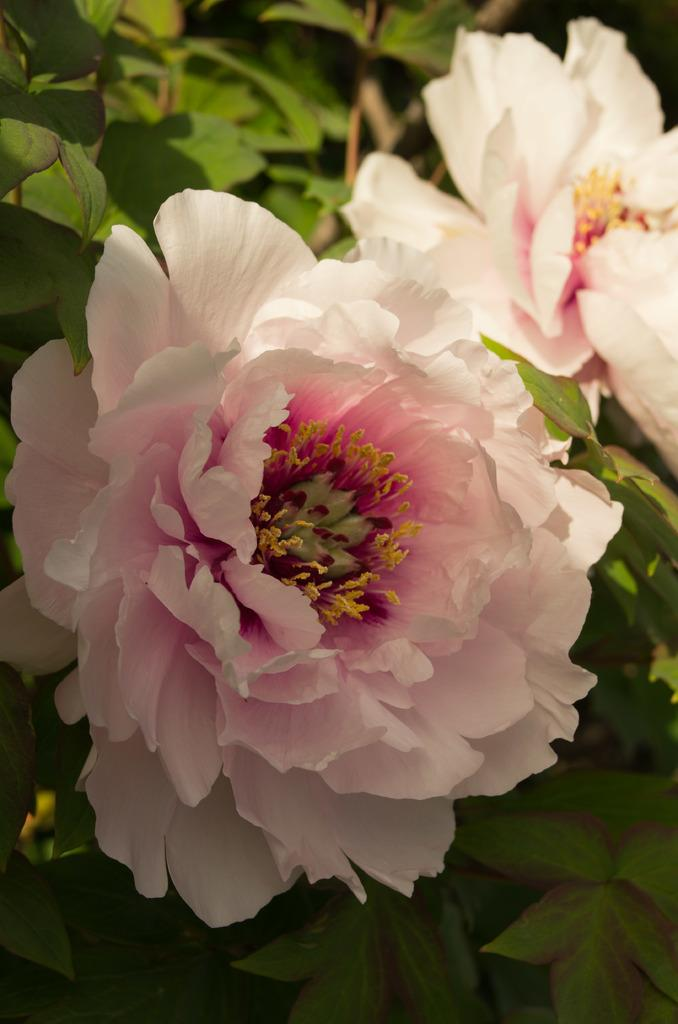What is present in the image? There is a plant in the image. What can be observed on the plant? There are flowers on the plant. How does the stranger interact with the plant in the image? There is no stranger present in the image, so it is not possible to answer that question. 